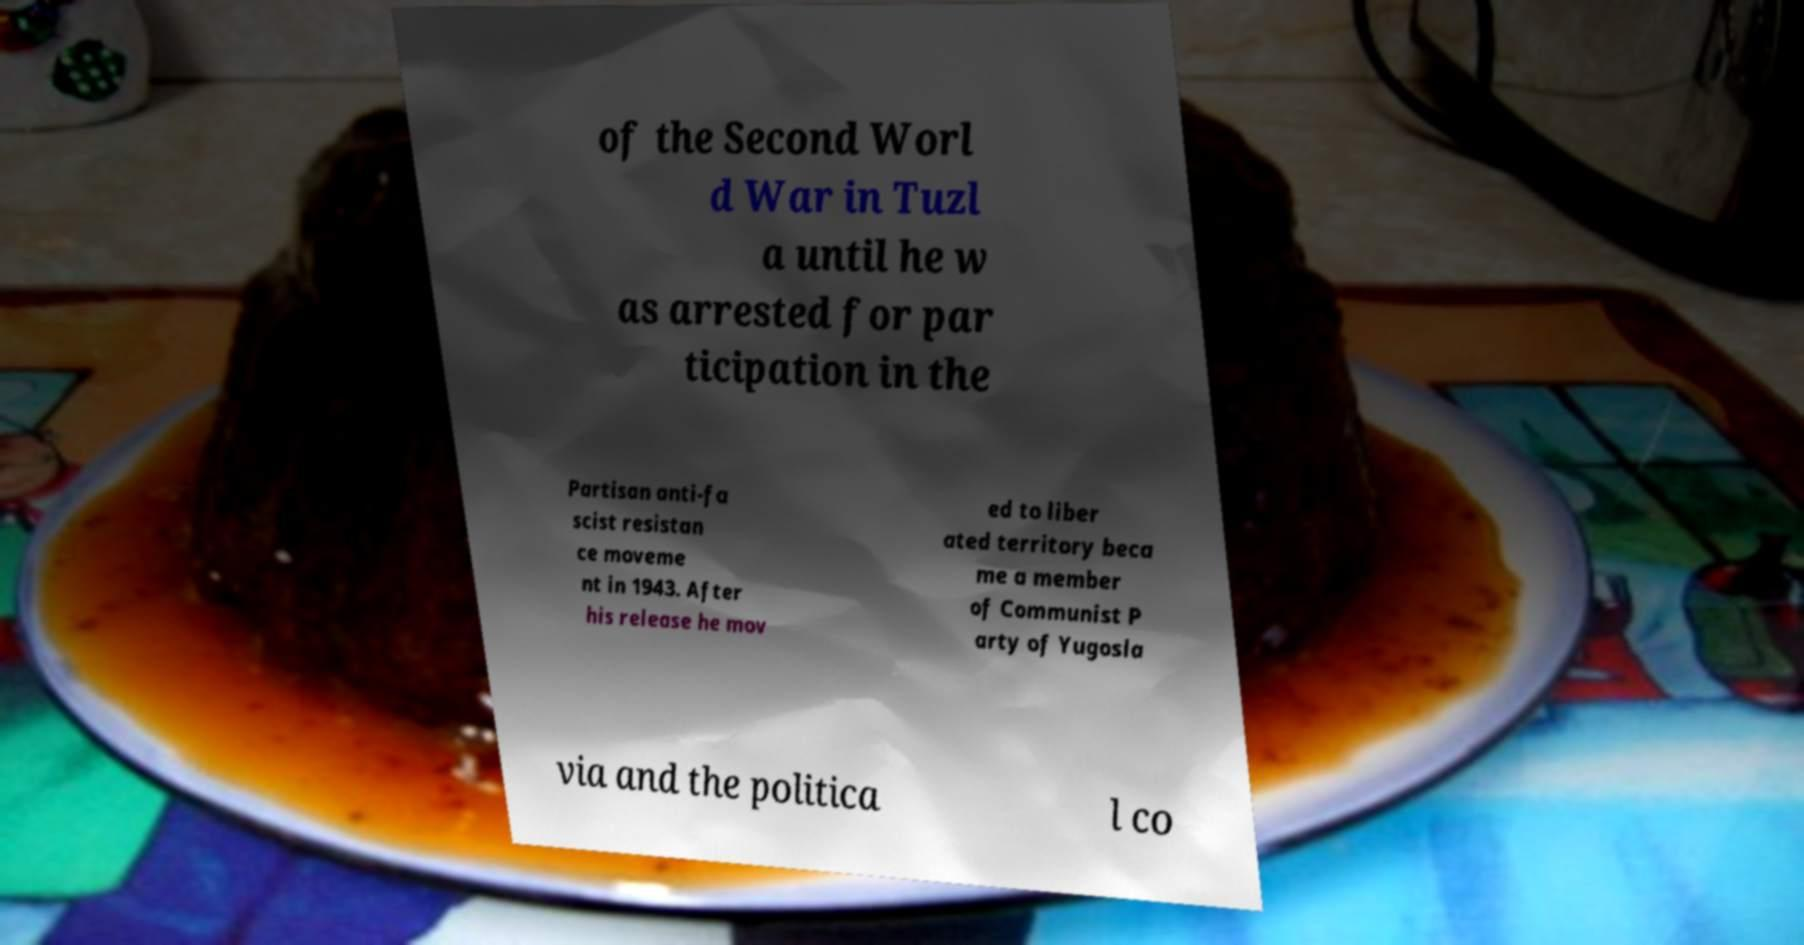For documentation purposes, I need the text within this image transcribed. Could you provide that? of the Second Worl d War in Tuzl a until he w as arrested for par ticipation in the Partisan anti-fa scist resistan ce moveme nt in 1943. After his release he mov ed to liber ated territory beca me a member of Communist P arty of Yugosla via and the politica l co 